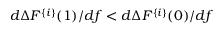Convert formula to latex. <formula><loc_0><loc_0><loc_500><loc_500>d \Delta F ^ { \{ i \} } ( 1 ) / d f < d \Delta F ^ { \{ i \} } ( 0 ) / d f</formula> 